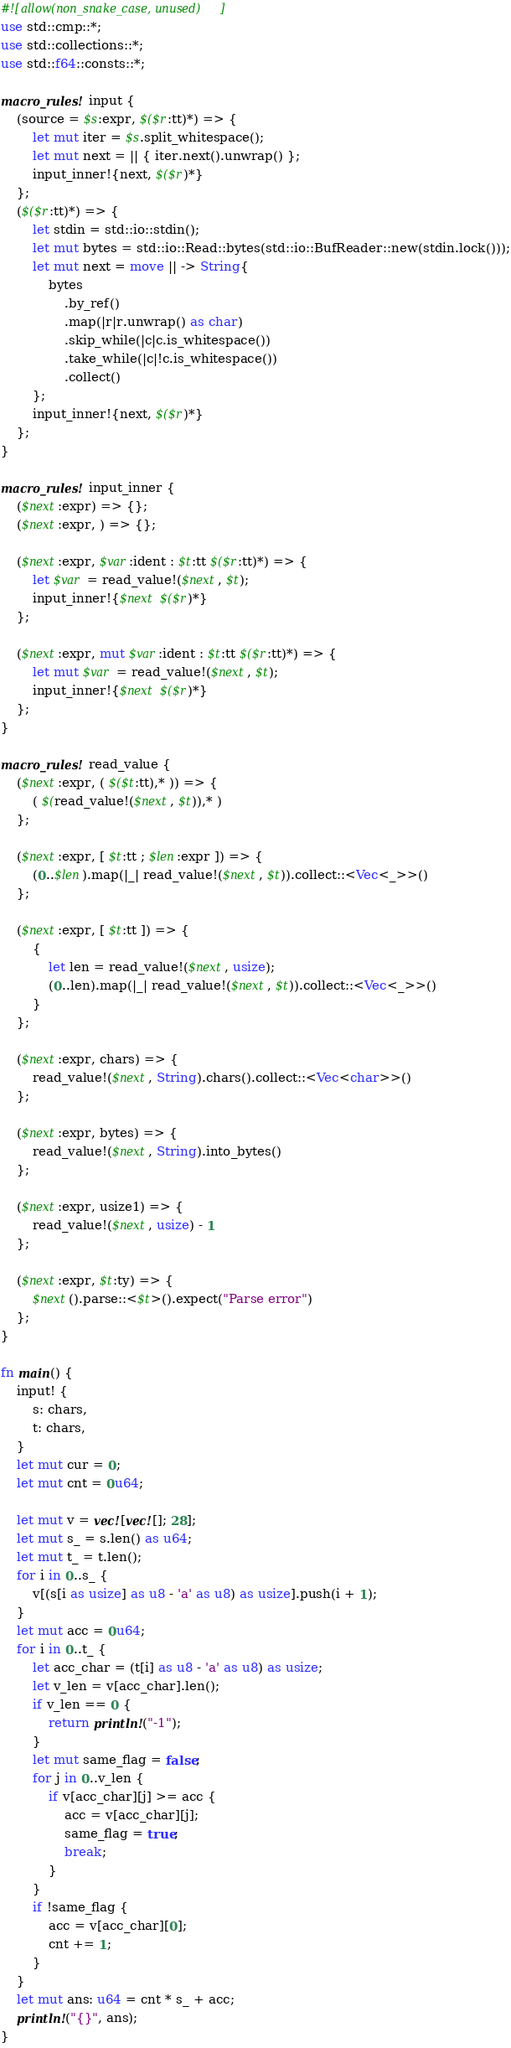Convert code to text. <code><loc_0><loc_0><loc_500><loc_500><_Rust_>#![allow(non_snake_case, unused)]
use std::cmp::*;
use std::collections::*;
use std::f64::consts::*;

macro_rules! input {
    (source = $s:expr, $($r:tt)*) => {
        let mut iter = $s.split_whitespace();
        let mut next = || { iter.next().unwrap() };
        input_inner!{next, $($r)*}
    };
    ($($r:tt)*) => {
        let stdin = std::io::stdin();
        let mut bytes = std::io::Read::bytes(std::io::BufReader::new(stdin.lock()));
        let mut next = move || -> String{
            bytes
                .by_ref()
                .map(|r|r.unwrap() as char)
                .skip_while(|c|c.is_whitespace())
                .take_while(|c|!c.is_whitespace())
                .collect()
        };
        input_inner!{next, $($r)*}
    };
}

macro_rules! input_inner {
    ($next:expr) => {};
    ($next:expr, ) => {};

    ($next:expr, $var:ident : $t:tt $($r:tt)*) => {
        let $var = read_value!($next, $t);
        input_inner!{$next $($r)*}
    };

    ($next:expr, mut $var:ident : $t:tt $($r:tt)*) => {
        let mut $var = read_value!($next, $t);
        input_inner!{$next $($r)*}
    };
}

macro_rules! read_value {
    ($next:expr, ( $($t:tt),* )) => {
        ( $(read_value!($next, $t)),* )
    };

    ($next:expr, [ $t:tt ; $len:expr ]) => {
        (0..$len).map(|_| read_value!($next, $t)).collect::<Vec<_>>()
    };

    ($next:expr, [ $t:tt ]) => {
        {
            let len = read_value!($next, usize);
            (0..len).map(|_| read_value!($next, $t)).collect::<Vec<_>>()
        }
    };

    ($next:expr, chars) => {
        read_value!($next, String).chars().collect::<Vec<char>>()
    };

    ($next:expr, bytes) => {
        read_value!($next, String).into_bytes()
    };

    ($next:expr, usize1) => {
        read_value!($next, usize) - 1
    };

    ($next:expr, $t:ty) => {
        $next().parse::<$t>().expect("Parse error")
    };
}

fn main() {
    input! {
        s: chars,
        t: chars,
    }
    let mut cur = 0;
    let mut cnt = 0u64;

    let mut v = vec![vec![]; 28];
    let mut s_ = s.len() as u64;
    let mut t_ = t.len();
    for i in 0..s_ {
        v[(s[i as usize] as u8 - 'a' as u8) as usize].push(i + 1);
    }
    let mut acc = 0u64;
    for i in 0..t_ {
        let acc_char = (t[i] as u8 - 'a' as u8) as usize;
        let v_len = v[acc_char].len();
        if v_len == 0 {
            return println!("-1");
        }
        let mut same_flag = false;
        for j in 0..v_len {
            if v[acc_char][j] >= acc {
                acc = v[acc_char][j];
                same_flag = true;
                break;
            }
        }
        if !same_flag {
            acc = v[acc_char][0];
            cnt += 1;
        }
    }
    let mut ans: u64 = cnt * s_ + acc;
    println!("{}", ans);
}
</code> 